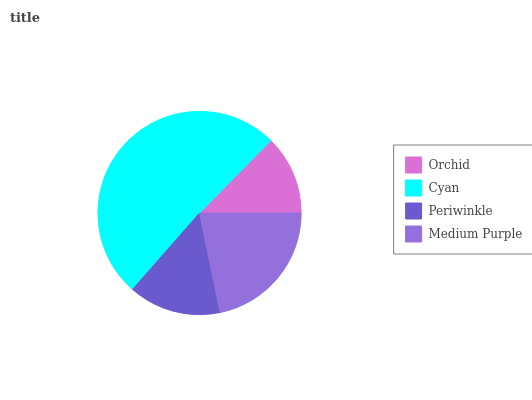Is Orchid the minimum?
Answer yes or no. Yes. Is Cyan the maximum?
Answer yes or no. Yes. Is Periwinkle the minimum?
Answer yes or no. No. Is Periwinkle the maximum?
Answer yes or no. No. Is Cyan greater than Periwinkle?
Answer yes or no. Yes. Is Periwinkle less than Cyan?
Answer yes or no. Yes. Is Periwinkle greater than Cyan?
Answer yes or no. No. Is Cyan less than Periwinkle?
Answer yes or no. No. Is Medium Purple the high median?
Answer yes or no. Yes. Is Periwinkle the low median?
Answer yes or no. Yes. Is Orchid the high median?
Answer yes or no. No. Is Cyan the low median?
Answer yes or no. No. 